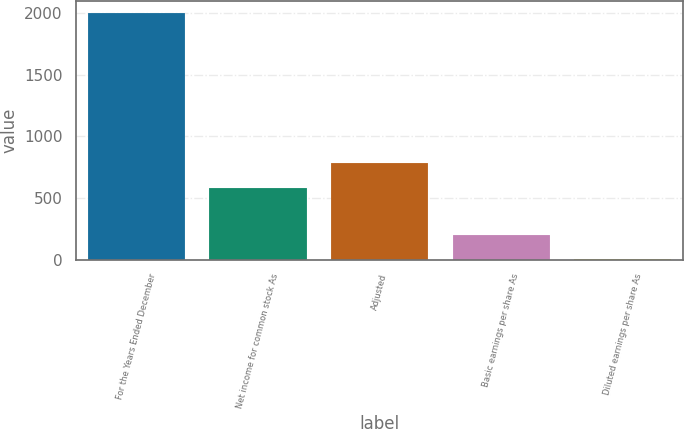<chart> <loc_0><loc_0><loc_500><loc_500><bar_chart><fcel>For the Years Ended December<fcel>Net income for common stock As<fcel>Adjusted<fcel>Basic earnings per share As<fcel>Diluted earnings per share As<nl><fcel>2000<fcel>582.8<fcel>782.53<fcel>202.47<fcel>2.74<nl></chart> 